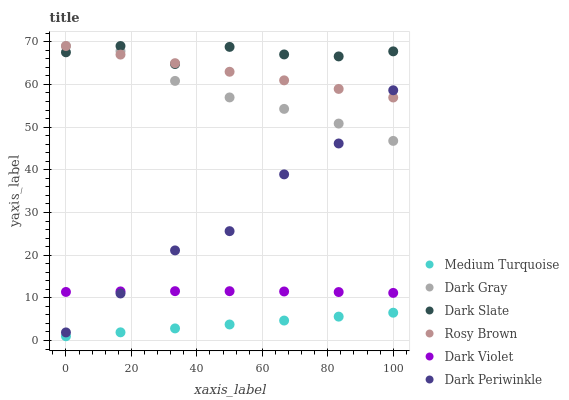Does Medium Turquoise have the minimum area under the curve?
Answer yes or no. Yes. Does Dark Slate have the maximum area under the curve?
Answer yes or no. Yes. Does Dark Violet have the minimum area under the curve?
Answer yes or no. No. Does Dark Violet have the maximum area under the curve?
Answer yes or no. No. Is Medium Turquoise the smoothest?
Answer yes or no. Yes. Is Dark Periwinkle the roughest?
Answer yes or no. Yes. Is Dark Violet the smoothest?
Answer yes or no. No. Is Dark Violet the roughest?
Answer yes or no. No. Does Medium Turquoise have the lowest value?
Answer yes or no. Yes. Does Dark Violet have the lowest value?
Answer yes or no. No. Does Dark Slate have the highest value?
Answer yes or no. Yes. Does Dark Violet have the highest value?
Answer yes or no. No. Is Dark Violet less than Dark Slate?
Answer yes or no. Yes. Is Dark Violet greater than Medium Turquoise?
Answer yes or no. Yes. Does Rosy Brown intersect Dark Periwinkle?
Answer yes or no. Yes. Is Rosy Brown less than Dark Periwinkle?
Answer yes or no. No. Is Rosy Brown greater than Dark Periwinkle?
Answer yes or no. No. Does Dark Violet intersect Dark Slate?
Answer yes or no. No. 